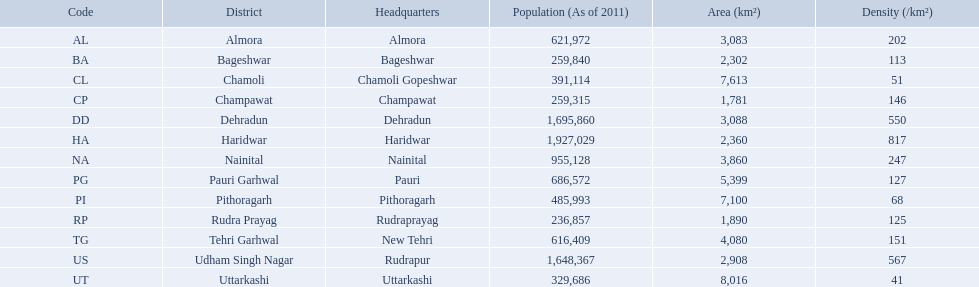What are the values for density of the districts of uttrakhand? 202, 113, 51, 146, 550, 817, 247, 127, 68, 125, 151, 567, 41. Which district has value of 51? Chamoli. What are all the regions? Almora, Bageshwar, Chamoli, Champawat, Dehradun, Haridwar, Nainital, Pauri Garhwal, Pithoragarh, Rudra Prayag, Tehri Garhwal, Udham Singh Nagar, Uttarkashi. And their population concentrations? 202, 113, 51, 146, 550, 817, 247, 127, 68, 125, 151, 567, 41. Now, which region has a concentration of 51? Chamoli. What are the titles of every district? Almora, Bageshwar, Chamoli, Champawat, Dehradun, Haridwar, Nainital, Pauri Garhwal, Pithoragarh, Rudra Prayag, Tehri Garhwal, Udham Singh Nagar, Uttarkashi. What is the spectrum of densities covered by these districts? 202, 113, 51, 146, 550, 817, 247, 127, 68, 125, 151, 567, 41. Which district possesses a density of 51? Chamoli. Can you list all the district names? Almora, Bageshwar, Chamoli, Champawat, Dehradun, Haridwar, Nainital, Pauri Garhwal, Pithoragarh, Rudra Prayag, Tehri Garhwal, Udham Singh Nagar, Uttarkashi. What is the variety of densities found in these districts? 202, 113, 51, 146, 550, 817, 247, 127, 68, 125, 151, 567, 41. Which district is characterized by a density of 51? Chamoli. 